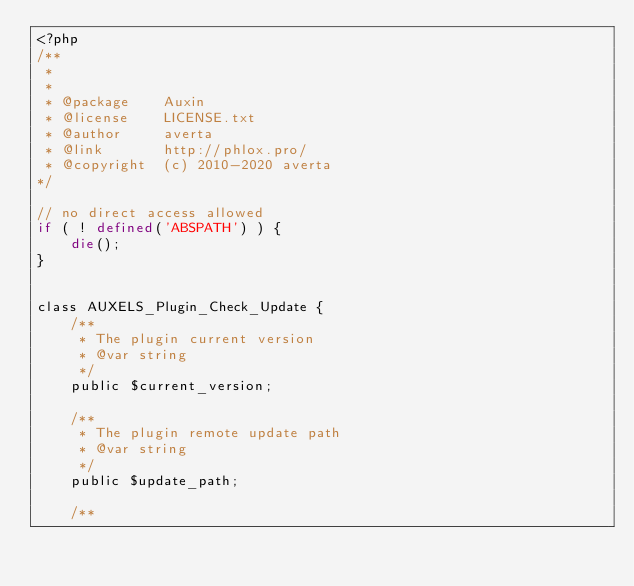Convert code to text. <code><loc_0><loc_0><loc_500><loc_500><_PHP_><?php
/**
 *
 * 
 * @package    Auxin
 * @license    LICENSE.txt
 * @author     averta
 * @link       http://phlox.pro/
 * @copyright  (c) 2010-2020 averta
*/

// no direct access allowed
if ( ! defined('ABSPATH') ) {
    die();
}


class AUXELS_Plugin_Check_Update {
    /**
     * The plugin current version
     * @var string
     */
    public $current_version;

    /**
     * The plugin remote update path
     * @var string
     */
    public $update_path;

    /**</code> 